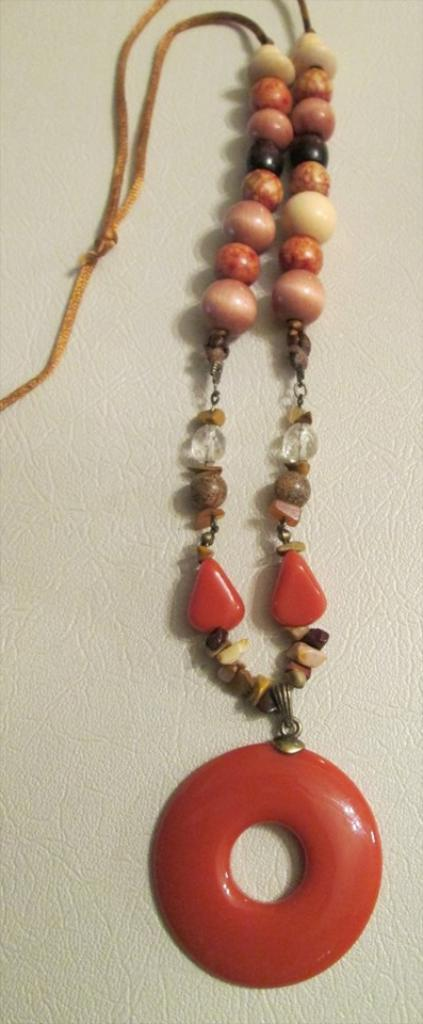What is the main subject of the image? There is an ornament in the image. Can you describe the colors of the ornament? The ornament is in orange and brown colors. What is the color of the background at the bottom of the image? The background at the bottom of the image is white. What type of rod is used to hang the ornament in the image? There is no rod visible in the image, and therefore it cannot be determined what type of rod is used to hang the ornament. 